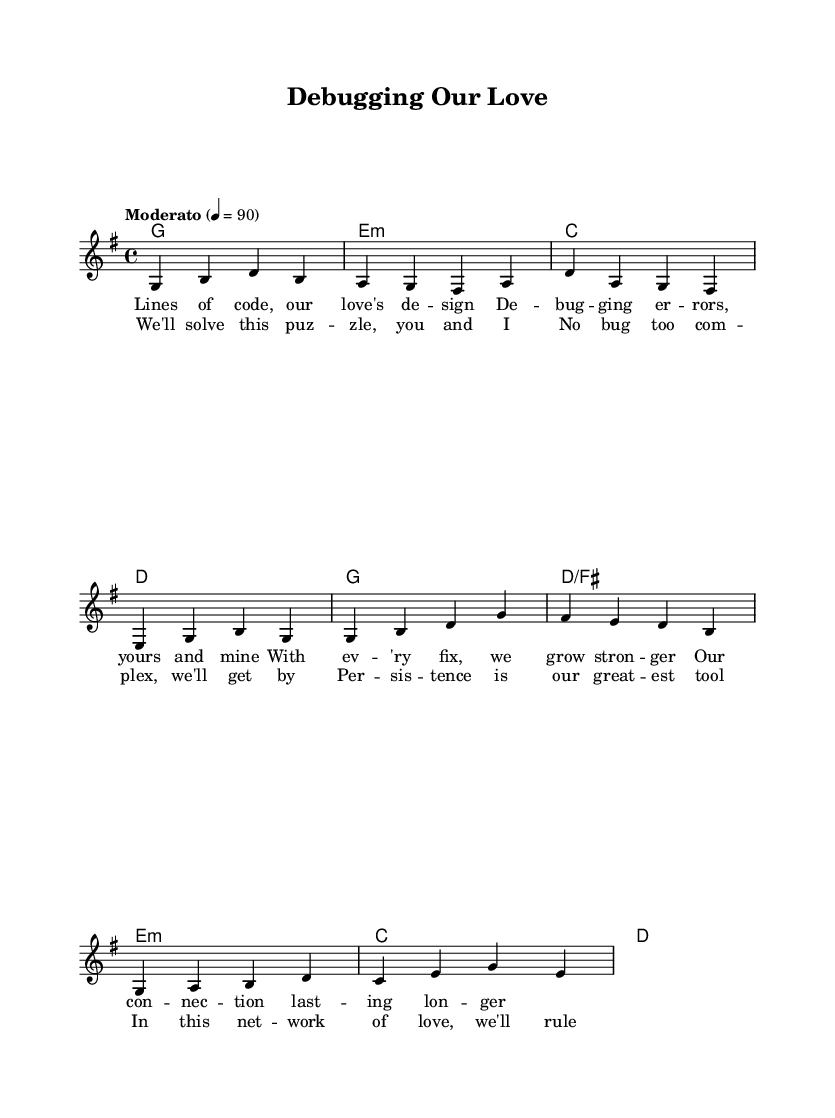What is the key signature of this music? The key signature is G major, which has one sharp (F#). This can be determined by looking at the initial key signature indication in the global block of the sheet music.
Answer: G major What is the time signature of this music? The time signature is 4/4, as indicated in the global settings. This means there are four beats per measure and a quarter note receives one beat.
Answer: 4/4 What tempo is marked for this piece? The tempo is marked as "Moderato," set to a metronome marking of 90 beats per minute. This information is found in the global settings of the score.
Answer: Moderato, 90 How many measures are in the verse section? The verse section consists of four measures as portrayed in the melody part for the verse. Each measure is separated by a vertical line indicating the end of a measure.
Answer: Four What is the main theme of the lyrics presented? The main theme of the lyrics revolves around problem-solving and persistence in love, specifically comparing relationship challenges to debugging and coding. This can be inferred from both the verses and chorus content.
Answer: Problem-solving and persistence What is the chord that accompanies the first measure of the verse? The chord that accompanies the first measure of the verse is G major. This can be found in the harmonies section that aligns with the corresponding melody measures.
Answer: G major How do the chorus lyrics emphasize teamwork? The chorus lyrics emphasize teamwork by stating, "We'll solve this puzzle, you and I," which suggests collaboration in facing challenges. This highlights the importance of working together in a relationship.
Answer: Collaboration 